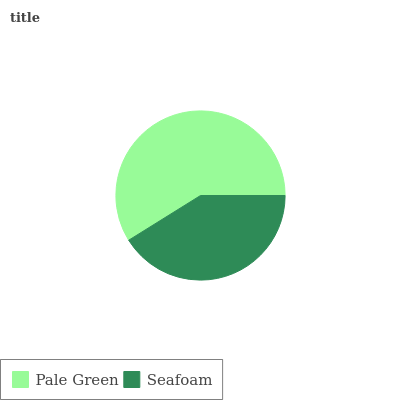Is Seafoam the minimum?
Answer yes or no. Yes. Is Pale Green the maximum?
Answer yes or no. Yes. Is Seafoam the maximum?
Answer yes or no. No. Is Pale Green greater than Seafoam?
Answer yes or no. Yes. Is Seafoam less than Pale Green?
Answer yes or no. Yes. Is Seafoam greater than Pale Green?
Answer yes or no. No. Is Pale Green less than Seafoam?
Answer yes or no. No. Is Pale Green the high median?
Answer yes or no. Yes. Is Seafoam the low median?
Answer yes or no. Yes. Is Seafoam the high median?
Answer yes or no. No. Is Pale Green the low median?
Answer yes or no. No. 